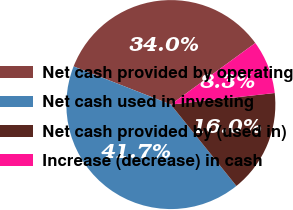Convert chart to OTSL. <chart><loc_0><loc_0><loc_500><loc_500><pie_chart><fcel>Net cash provided by operating<fcel>Net cash used in investing<fcel>Net cash provided by (used in)<fcel>Increase (decrease) in cash<nl><fcel>34.03%<fcel>41.74%<fcel>15.97%<fcel>8.26%<nl></chart> 